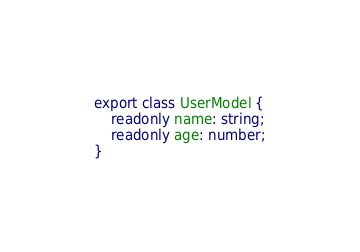Convert code to text. <code><loc_0><loc_0><loc_500><loc_500><_TypeScript_>export class UserModel {
    readonly name: string;
    readonly age: number;
}
</code> 